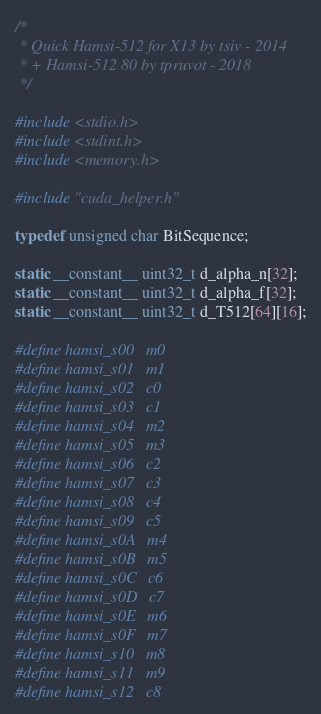<code> <loc_0><loc_0><loc_500><loc_500><_Cuda_>/*
 * Quick Hamsi-512 for X13 by tsiv - 2014
 * + Hamsi-512 80 by tpruvot - 2018
 */

#include <stdio.h>
#include <stdint.h>
#include <memory.h>

#include "cuda_helper.h"

typedef unsigned char BitSequence;

static __constant__ uint32_t d_alpha_n[32];
static __constant__ uint32_t d_alpha_f[32];
static __constant__ uint32_t d_T512[64][16];

#define hamsi_s00   m0
#define hamsi_s01   m1
#define hamsi_s02   c0
#define hamsi_s03   c1
#define hamsi_s04   m2
#define hamsi_s05   m3
#define hamsi_s06   c2
#define hamsi_s07   c3
#define hamsi_s08   c4
#define hamsi_s09   c5
#define hamsi_s0A   m4
#define hamsi_s0B   m5
#define hamsi_s0C   c6
#define hamsi_s0D   c7
#define hamsi_s0E   m6
#define hamsi_s0F   m7
#define hamsi_s10   m8
#define hamsi_s11   m9
#define hamsi_s12   c8</code> 